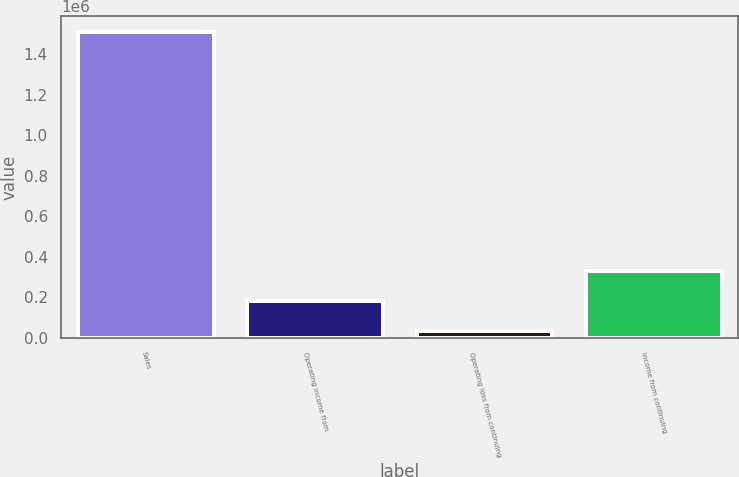Convert chart to OTSL. <chart><loc_0><loc_0><loc_500><loc_500><bar_chart><fcel>Sales<fcel>Operating income from<fcel>Operating loss from continuing<fcel>Income from continuing<nl><fcel>1.51256e+06<fcel>184394<fcel>36821<fcel>331968<nl></chart> 